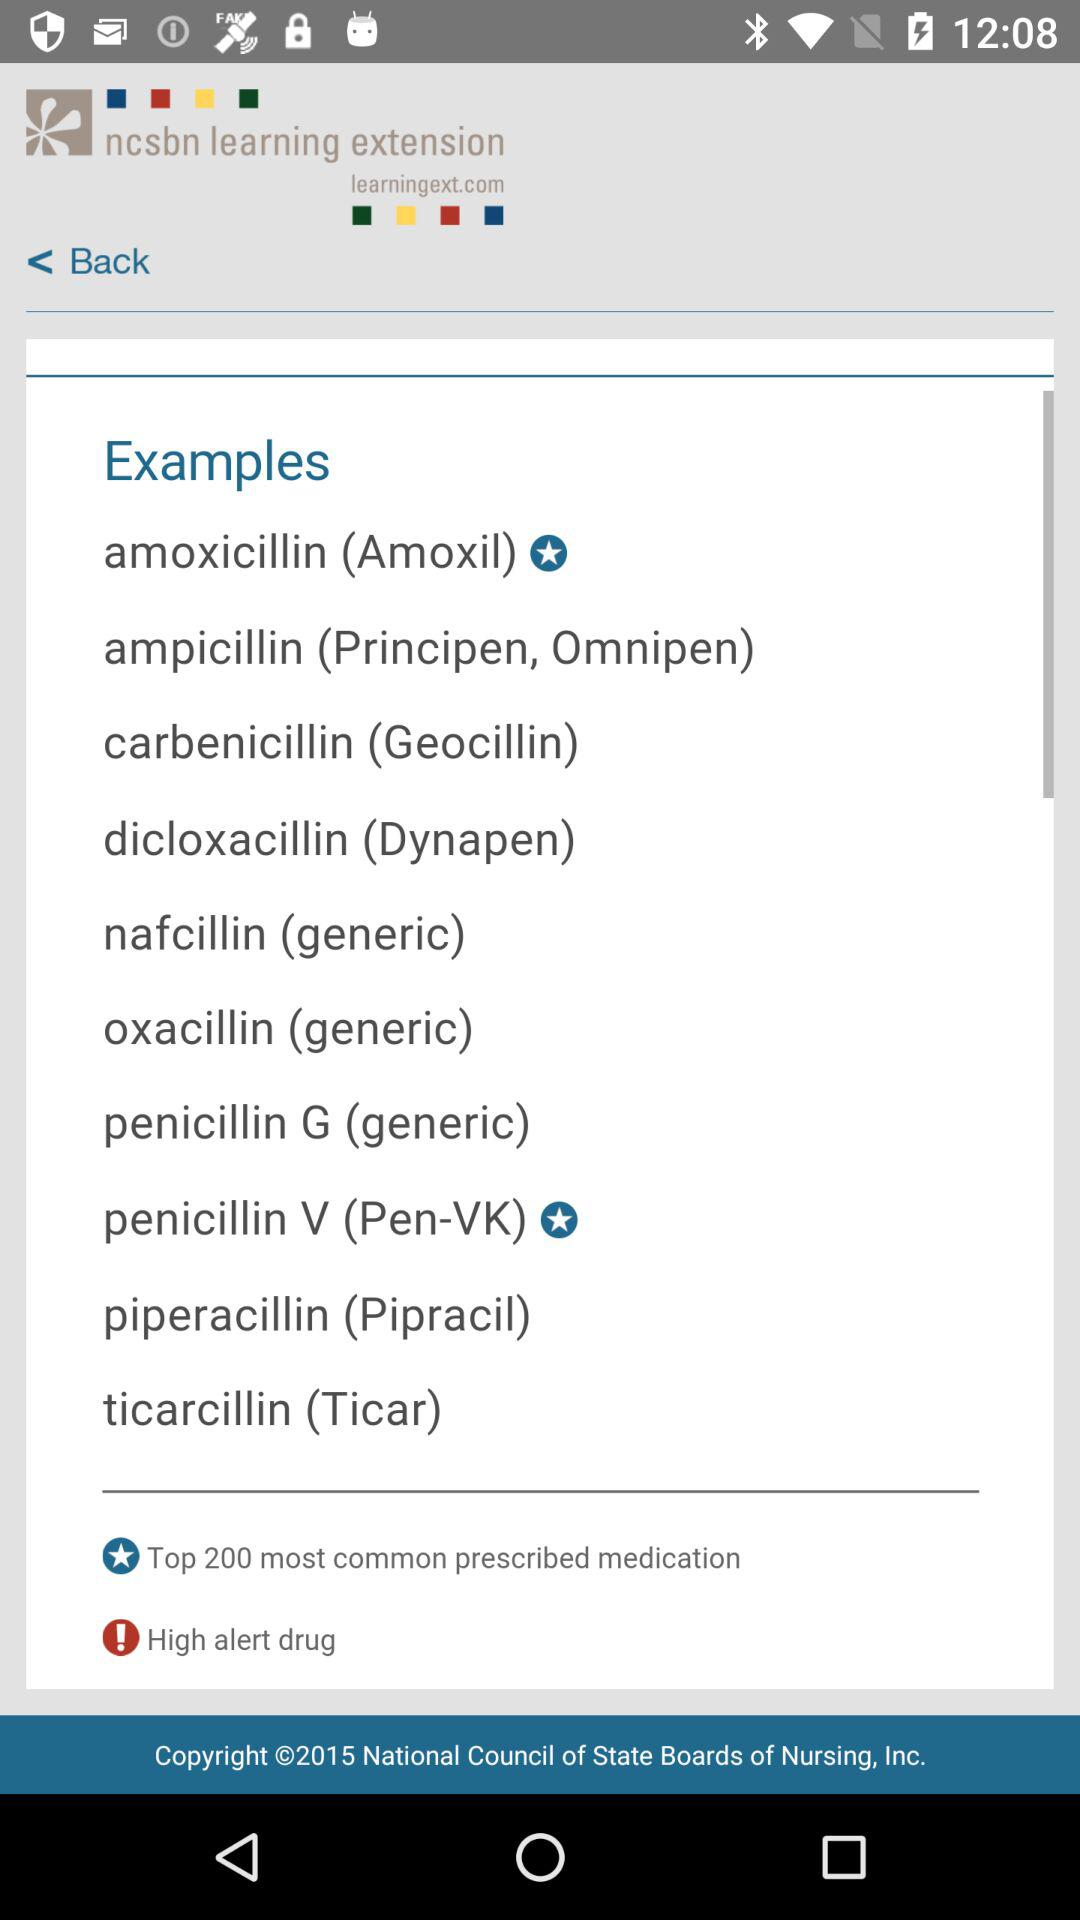Which symptoms does amoxicillin treat?
When the provided information is insufficient, respond with <no answer>. <no answer> 